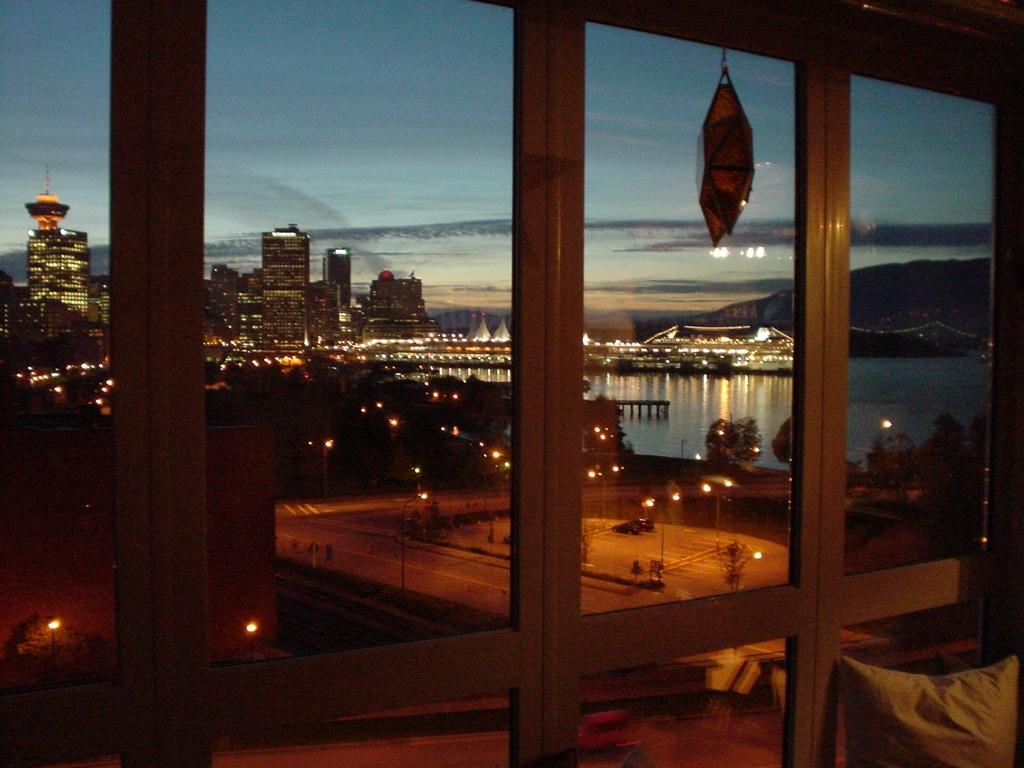What type of structure is present in the image? There is a glass window in the image. What can be seen through the window? Trees, light poles, buildings, a river, a mountain, and the sky are visible through the window. Can you describe the view through the window? The view includes a combination of natural and man-made elements, such as trees, light poles, buildings, a river, a mountain, and the sky. Can you tell me how many airplanes are flying over the mountain in the image? There are no airplanes visible in the image; it only shows a view through a window with various elements, including a mountain. What type of dog can be seen playing near the river in the image? There is no dog present in the image; it only shows a view through a window with various elements, including a river. 